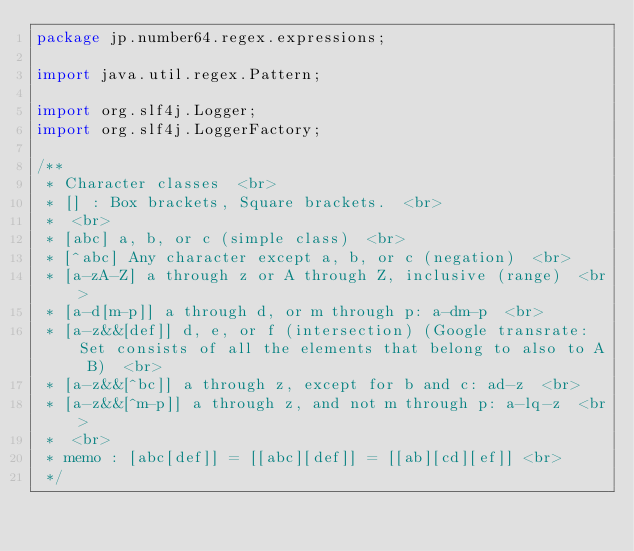<code> <loc_0><loc_0><loc_500><loc_500><_Java_>package jp.number64.regex.expressions;

import java.util.regex.Pattern;

import org.slf4j.Logger;
import org.slf4j.LoggerFactory;

/**
 * Character classes  <br>
 * [] : Box brackets, Square brackets.  <br>
 *  <br>
 * [abc] a, b, or c (simple class)  <br>
 * [^abc] Any character except a, b, or c (negation)  <br>
 * [a-zA-Z] a through z or A through Z, inclusive (range)  <br>
 * [a-d[m-p]] a through d, or m through p: a-dm-p  <br>
 * [a-z&&[def]] d, e, or f (intersection) (Google transrate: Set consists of all the elements that belong to also to A B)  <br>
 * [a-z&&[^bc]] a through z, except for b and c: ad-z  <br>
 * [a-z&&[^m-p]] a through z, and not m through p: a-lq-z  <br>
 *  <br>
 * memo : [abc[def]] = [[abc][def]] = [[ab][cd][ef]] <br>
 */</code> 